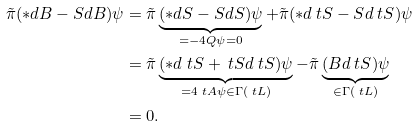Convert formula to latex. <formula><loc_0><loc_0><loc_500><loc_500>\tilde { \pi } ( * d B - S d B ) \psi & = \tilde { \pi } \underbrace { ( * d S - S d S ) \psi } _ { = - 4 Q \psi = 0 } + \tilde { \pi } ( * d \ t S - S d \ t S ) \psi \\ & = \tilde { \pi } \underbrace { ( * d \ t S + \ t S d \ t S ) \psi } _ { = 4 \ t A \psi \in \Gamma ( \ t L ) } - \tilde { \pi } \underbrace { ( B d \ t S ) \psi } _ { \in \Gamma ( \ t L ) } \\ & = 0 .</formula> 